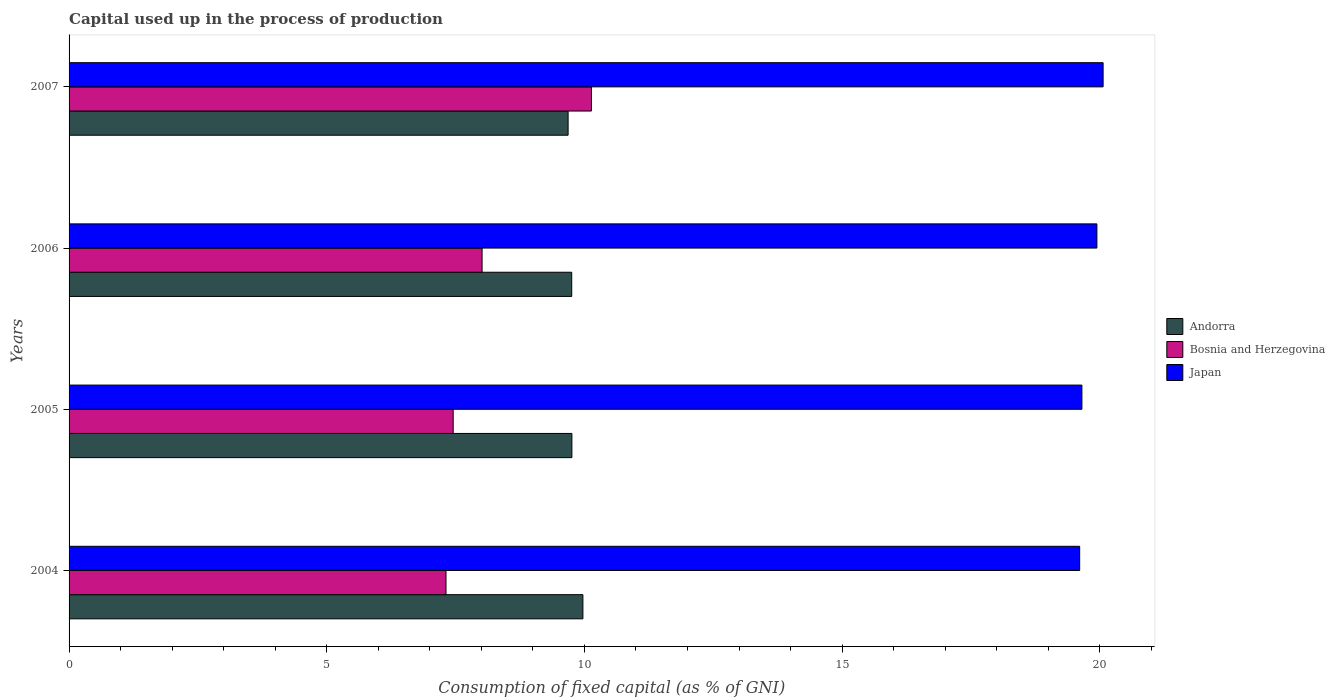How many different coloured bars are there?
Ensure brevity in your answer.  3. How many groups of bars are there?
Keep it short and to the point. 4. Are the number of bars per tick equal to the number of legend labels?
Give a very brief answer. Yes. How many bars are there on the 1st tick from the top?
Your answer should be very brief. 3. How many bars are there on the 3rd tick from the bottom?
Make the answer very short. 3. What is the capital used up in the process of production in Bosnia and Herzegovina in 2005?
Make the answer very short. 7.45. Across all years, what is the maximum capital used up in the process of production in Andorra?
Give a very brief answer. 9.97. Across all years, what is the minimum capital used up in the process of production in Japan?
Keep it short and to the point. 19.61. What is the total capital used up in the process of production in Japan in the graph?
Give a very brief answer. 79.28. What is the difference between the capital used up in the process of production in Japan in 2006 and that in 2007?
Your answer should be very brief. -0.12. What is the difference between the capital used up in the process of production in Japan in 2006 and the capital used up in the process of production in Andorra in 2005?
Offer a very short reply. 10.19. What is the average capital used up in the process of production in Andorra per year?
Give a very brief answer. 9.79. In the year 2004, what is the difference between the capital used up in the process of production in Japan and capital used up in the process of production in Bosnia and Herzegovina?
Make the answer very short. 12.3. What is the ratio of the capital used up in the process of production in Andorra in 2006 to that in 2007?
Your answer should be compact. 1.01. Is the capital used up in the process of production in Bosnia and Herzegovina in 2006 less than that in 2007?
Your response must be concise. Yes. What is the difference between the highest and the second highest capital used up in the process of production in Bosnia and Herzegovina?
Offer a terse response. 2.12. What is the difference between the highest and the lowest capital used up in the process of production in Japan?
Your answer should be very brief. 0.45. Is the sum of the capital used up in the process of production in Bosnia and Herzegovina in 2004 and 2005 greater than the maximum capital used up in the process of production in Japan across all years?
Ensure brevity in your answer.  No. What does the 3rd bar from the top in 2005 represents?
Your response must be concise. Andorra. Is it the case that in every year, the sum of the capital used up in the process of production in Andorra and capital used up in the process of production in Japan is greater than the capital used up in the process of production in Bosnia and Herzegovina?
Offer a very short reply. Yes. How many bars are there?
Ensure brevity in your answer.  12. Are all the bars in the graph horizontal?
Provide a succinct answer. Yes. What is the difference between two consecutive major ticks on the X-axis?
Give a very brief answer. 5. Does the graph contain any zero values?
Provide a short and direct response. No. Where does the legend appear in the graph?
Provide a short and direct response. Center right. How are the legend labels stacked?
Offer a terse response. Vertical. What is the title of the graph?
Your response must be concise. Capital used up in the process of production. What is the label or title of the X-axis?
Provide a succinct answer. Consumption of fixed capital (as % of GNI). What is the label or title of the Y-axis?
Ensure brevity in your answer.  Years. What is the Consumption of fixed capital (as % of GNI) of Andorra in 2004?
Your response must be concise. 9.97. What is the Consumption of fixed capital (as % of GNI) in Bosnia and Herzegovina in 2004?
Your response must be concise. 7.31. What is the Consumption of fixed capital (as % of GNI) in Japan in 2004?
Ensure brevity in your answer.  19.61. What is the Consumption of fixed capital (as % of GNI) in Andorra in 2005?
Keep it short and to the point. 9.76. What is the Consumption of fixed capital (as % of GNI) of Bosnia and Herzegovina in 2005?
Your answer should be compact. 7.45. What is the Consumption of fixed capital (as % of GNI) in Japan in 2005?
Your response must be concise. 19.65. What is the Consumption of fixed capital (as % of GNI) in Andorra in 2006?
Your answer should be compact. 9.75. What is the Consumption of fixed capital (as % of GNI) of Bosnia and Herzegovina in 2006?
Offer a very short reply. 8.01. What is the Consumption of fixed capital (as % of GNI) of Japan in 2006?
Provide a succinct answer. 19.95. What is the Consumption of fixed capital (as % of GNI) in Andorra in 2007?
Provide a short and direct response. 9.68. What is the Consumption of fixed capital (as % of GNI) of Bosnia and Herzegovina in 2007?
Your answer should be very brief. 10.14. What is the Consumption of fixed capital (as % of GNI) of Japan in 2007?
Your answer should be compact. 20.07. Across all years, what is the maximum Consumption of fixed capital (as % of GNI) in Andorra?
Provide a succinct answer. 9.97. Across all years, what is the maximum Consumption of fixed capital (as % of GNI) of Bosnia and Herzegovina?
Your response must be concise. 10.14. Across all years, what is the maximum Consumption of fixed capital (as % of GNI) of Japan?
Ensure brevity in your answer.  20.07. Across all years, what is the minimum Consumption of fixed capital (as % of GNI) in Andorra?
Provide a succinct answer. 9.68. Across all years, what is the minimum Consumption of fixed capital (as % of GNI) in Bosnia and Herzegovina?
Your response must be concise. 7.31. Across all years, what is the minimum Consumption of fixed capital (as % of GNI) in Japan?
Provide a short and direct response. 19.61. What is the total Consumption of fixed capital (as % of GNI) in Andorra in the graph?
Your answer should be compact. 39.17. What is the total Consumption of fixed capital (as % of GNI) of Bosnia and Herzegovina in the graph?
Provide a short and direct response. 32.92. What is the total Consumption of fixed capital (as % of GNI) of Japan in the graph?
Ensure brevity in your answer.  79.28. What is the difference between the Consumption of fixed capital (as % of GNI) of Andorra in 2004 and that in 2005?
Offer a very short reply. 0.21. What is the difference between the Consumption of fixed capital (as % of GNI) of Bosnia and Herzegovina in 2004 and that in 2005?
Your answer should be very brief. -0.14. What is the difference between the Consumption of fixed capital (as % of GNI) of Japan in 2004 and that in 2005?
Give a very brief answer. -0.04. What is the difference between the Consumption of fixed capital (as % of GNI) in Andorra in 2004 and that in 2006?
Your answer should be very brief. 0.22. What is the difference between the Consumption of fixed capital (as % of GNI) in Bosnia and Herzegovina in 2004 and that in 2006?
Provide a short and direct response. -0.7. What is the difference between the Consumption of fixed capital (as % of GNI) in Japan in 2004 and that in 2006?
Provide a short and direct response. -0.33. What is the difference between the Consumption of fixed capital (as % of GNI) of Andorra in 2004 and that in 2007?
Your answer should be compact. 0.29. What is the difference between the Consumption of fixed capital (as % of GNI) in Bosnia and Herzegovina in 2004 and that in 2007?
Provide a succinct answer. -2.82. What is the difference between the Consumption of fixed capital (as % of GNI) in Japan in 2004 and that in 2007?
Your response must be concise. -0.45. What is the difference between the Consumption of fixed capital (as % of GNI) of Andorra in 2005 and that in 2006?
Your answer should be very brief. 0. What is the difference between the Consumption of fixed capital (as % of GNI) in Bosnia and Herzegovina in 2005 and that in 2006?
Give a very brief answer. -0.56. What is the difference between the Consumption of fixed capital (as % of GNI) in Japan in 2005 and that in 2006?
Provide a succinct answer. -0.29. What is the difference between the Consumption of fixed capital (as % of GNI) of Andorra in 2005 and that in 2007?
Give a very brief answer. 0.07. What is the difference between the Consumption of fixed capital (as % of GNI) in Bosnia and Herzegovina in 2005 and that in 2007?
Give a very brief answer. -2.68. What is the difference between the Consumption of fixed capital (as % of GNI) in Japan in 2005 and that in 2007?
Your answer should be compact. -0.41. What is the difference between the Consumption of fixed capital (as % of GNI) of Andorra in 2006 and that in 2007?
Ensure brevity in your answer.  0.07. What is the difference between the Consumption of fixed capital (as % of GNI) in Bosnia and Herzegovina in 2006 and that in 2007?
Provide a short and direct response. -2.12. What is the difference between the Consumption of fixed capital (as % of GNI) of Japan in 2006 and that in 2007?
Offer a terse response. -0.12. What is the difference between the Consumption of fixed capital (as % of GNI) in Andorra in 2004 and the Consumption of fixed capital (as % of GNI) in Bosnia and Herzegovina in 2005?
Offer a very short reply. 2.52. What is the difference between the Consumption of fixed capital (as % of GNI) in Andorra in 2004 and the Consumption of fixed capital (as % of GNI) in Japan in 2005?
Offer a very short reply. -9.68. What is the difference between the Consumption of fixed capital (as % of GNI) of Bosnia and Herzegovina in 2004 and the Consumption of fixed capital (as % of GNI) of Japan in 2005?
Give a very brief answer. -12.34. What is the difference between the Consumption of fixed capital (as % of GNI) of Andorra in 2004 and the Consumption of fixed capital (as % of GNI) of Bosnia and Herzegovina in 2006?
Offer a terse response. 1.96. What is the difference between the Consumption of fixed capital (as % of GNI) in Andorra in 2004 and the Consumption of fixed capital (as % of GNI) in Japan in 2006?
Ensure brevity in your answer.  -9.97. What is the difference between the Consumption of fixed capital (as % of GNI) in Bosnia and Herzegovina in 2004 and the Consumption of fixed capital (as % of GNI) in Japan in 2006?
Ensure brevity in your answer.  -12.63. What is the difference between the Consumption of fixed capital (as % of GNI) of Andorra in 2004 and the Consumption of fixed capital (as % of GNI) of Bosnia and Herzegovina in 2007?
Your response must be concise. -0.17. What is the difference between the Consumption of fixed capital (as % of GNI) in Andorra in 2004 and the Consumption of fixed capital (as % of GNI) in Japan in 2007?
Make the answer very short. -10.09. What is the difference between the Consumption of fixed capital (as % of GNI) of Bosnia and Herzegovina in 2004 and the Consumption of fixed capital (as % of GNI) of Japan in 2007?
Offer a terse response. -12.75. What is the difference between the Consumption of fixed capital (as % of GNI) in Andorra in 2005 and the Consumption of fixed capital (as % of GNI) in Bosnia and Herzegovina in 2006?
Offer a terse response. 1.74. What is the difference between the Consumption of fixed capital (as % of GNI) in Andorra in 2005 and the Consumption of fixed capital (as % of GNI) in Japan in 2006?
Make the answer very short. -10.19. What is the difference between the Consumption of fixed capital (as % of GNI) in Bosnia and Herzegovina in 2005 and the Consumption of fixed capital (as % of GNI) in Japan in 2006?
Give a very brief answer. -12.49. What is the difference between the Consumption of fixed capital (as % of GNI) in Andorra in 2005 and the Consumption of fixed capital (as % of GNI) in Bosnia and Herzegovina in 2007?
Make the answer very short. -0.38. What is the difference between the Consumption of fixed capital (as % of GNI) of Andorra in 2005 and the Consumption of fixed capital (as % of GNI) of Japan in 2007?
Offer a very short reply. -10.31. What is the difference between the Consumption of fixed capital (as % of GNI) of Bosnia and Herzegovina in 2005 and the Consumption of fixed capital (as % of GNI) of Japan in 2007?
Offer a very short reply. -12.61. What is the difference between the Consumption of fixed capital (as % of GNI) of Andorra in 2006 and the Consumption of fixed capital (as % of GNI) of Bosnia and Herzegovina in 2007?
Keep it short and to the point. -0.38. What is the difference between the Consumption of fixed capital (as % of GNI) in Andorra in 2006 and the Consumption of fixed capital (as % of GNI) in Japan in 2007?
Your answer should be compact. -10.31. What is the difference between the Consumption of fixed capital (as % of GNI) in Bosnia and Herzegovina in 2006 and the Consumption of fixed capital (as % of GNI) in Japan in 2007?
Provide a short and direct response. -12.05. What is the average Consumption of fixed capital (as % of GNI) in Andorra per year?
Make the answer very short. 9.79. What is the average Consumption of fixed capital (as % of GNI) of Bosnia and Herzegovina per year?
Provide a succinct answer. 8.23. What is the average Consumption of fixed capital (as % of GNI) of Japan per year?
Keep it short and to the point. 19.82. In the year 2004, what is the difference between the Consumption of fixed capital (as % of GNI) of Andorra and Consumption of fixed capital (as % of GNI) of Bosnia and Herzegovina?
Give a very brief answer. 2.66. In the year 2004, what is the difference between the Consumption of fixed capital (as % of GNI) of Andorra and Consumption of fixed capital (as % of GNI) of Japan?
Your answer should be very brief. -9.64. In the year 2004, what is the difference between the Consumption of fixed capital (as % of GNI) in Bosnia and Herzegovina and Consumption of fixed capital (as % of GNI) in Japan?
Your answer should be compact. -12.3. In the year 2005, what is the difference between the Consumption of fixed capital (as % of GNI) in Andorra and Consumption of fixed capital (as % of GNI) in Bosnia and Herzegovina?
Provide a succinct answer. 2.3. In the year 2005, what is the difference between the Consumption of fixed capital (as % of GNI) in Andorra and Consumption of fixed capital (as % of GNI) in Japan?
Your response must be concise. -9.9. In the year 2005, what is the difference between the Consumption of fixed capital (as % of GNI) in Bosnia and Herzegovina and Consumption of fixed capital (as % of GNI) in Japan?
Your response must be concise. -12.2. In the year 2006, what is the difference between the Consumption of fixed capital (as % of GNI) in Andorra and Consumption of fixed capital (as % of GNI) in Bosnia and Herzegovina?
Your answer should be very brief. 1.74. In the year 2006, what is the difference between the Consumption of fixed capital (as % of GNI) in Andorra and Consumption of fixed capital (as % of GNI) in Japan?
Give a very brief answer. -10.19. In the year 2006, what is the difference between the Consumption of fixed capital (as % of GNI) in Bosnia and Herzegovina and Consumption of fixed capital (as % of GNI) in Japan?
Offer a terse response. -11.93. In the year 2007, what is the difference between the Consumption of fixed capital (as % of GNI) of Andorra and Consumption of fixed capital (as % of GNI) of Bosnia and Herzegovina?
Your answer should be compact. -0.45. In the year 2007, what is the difference between the Consumption of fixed capital (as % of GNI) of Andorra and Consumption of fixed capital (as % of GNI) of Japan?
Ensure brevity in your answer.  -10.38. In the year 2007, what is the difference between the Consumption of fixed capital (as % of GNI) in Bosnia and Herzegovina and Consumption of fixed capital (as % of GNI) in Japan?
Provide a succinct answer. -9.93. What is the ratio of the Consumption of fixed capital (as % of GNI) in Andorra in 2004 to that in 2005?
Your answer should be very brief. 1.02. What is the ratio of the Consumption of fixed capital (as % of GNI) in Bosnia and Herzegovina in 2004 to that in 2005?
Offer a terse response. 0.98. What is the ratio of the Consumption of fixed capital (as % of GNI) of Japan in 2004 to that in 2005?
Keep it short and to the point. 1. What is the ratio of the Consumption of fixed capital (as % of GNI) of Andorra in 2004 to that in 2006?
Your answer should be compact. 1.02. What is the ratio of the Consumption of fixed capital (as % of GNI) in Bosnia and Herzegovina in 2004 to that in 2006?
Keep it short and to the point. 0.91. What is the ratio of the Consumption of fixed capital (as % of GNI) of Japan in 2004 to that in 2006?
Keep it short and to the point. 0.98. What is the ratio of the Consumption of fixed capital (as % of GNI) in Andorra in 2004 to that in 2007?
Make the answer very short. 1.03. What is the ratio of the Consumption of fixed capital (as % of GNI) in Bosnia and Herzegovina in 2004 to that in 2007?
Keep it short and to the point. 0.72. What is the ratio of the Consumption of fixed capital (as % of GNI) of Japan in 2004 to that in 2007?
Your response must be concise. 0.98. What is the ratio of the Consumption of fixed capital (as % of GNI) of Andorra in 2005 to that in 2006?
Your answer should be compact. 1. What is the ratio of the Consumption of fixed capital (as % of GNI) in Bosnia and Herzegovina in 2005 to that in 2006?
Keep it short and to the point. 0.93. What is the ratio of the Consumption of fixed capital (as % of GNI) in Japan in 2005 to that in 2006?
Provide a short and direct response. 0.99. What is the ratio of the Consumption of fixed capital (as % of GNI) in Andorra in 2005 to that in 2007?
Provide a short and direct response. 1.01. What is the ratio of the Consumption of fixed capital (as % of GNI) in Bosnia and Herzegovina in 2005 to that in 2007?
Ensure brevity in your answer.  0.74. What is the ratio of the Consumption of fixed capital (as % of GNI) of Japan in 2005 to that in 2007?
Your response must be concise. 0.98. What is the ratio of the Consumption of fixed capital (as % of GNI) of Bosnia and Herzegovina in 2006 to that in 2007?
Ensure brevity in your answer.  0.79. What is the difference between the highest and the second highest Consumption of fixed capital (as % of GNI) in Andorra?
Give a very brief answer. 0.21. What is the difference between the highest and the second highest Consumption of fixed capital (as % of GNI) in Bosnia and Herzegovina?
Provide a succinct answer. 2.12. What is the difference between the highest and the second highest Consumption of fixed capital (as % of GNI) in Japan?
Provide a short and direct response. 0.12. What is the difference between the highest and the lowest Consumption of fixed capital (as % of GNI) in Andorra?
Offer a terse response. 0.29. What is the difference between the highest and the lowest Consumption of fixed capital (as % of GNI) in Bosnia and Herzegovina?
Offer a terse response. 2.82. What is the difference between the highest and the lowest Consumption of fixed capital (as % of GNI) in Japan?
Keep it short and to the point. 0.45. 